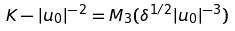Convert formula to latex. <formula><loc_0><loc_0><loc_500><loc_500>K - | u _ { 0 } | ^ { - 2 } = { M } _ { 3 } ( \delta ^ { 1 / 2 } | u _ { 0 } | ^ { - 3 } )</formula> 